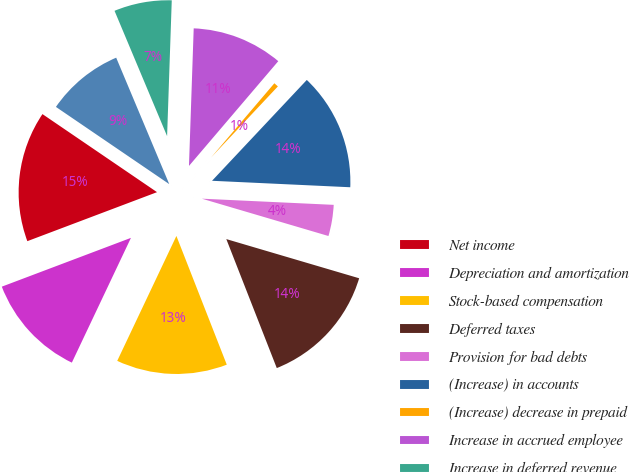<chart> <loc_0><loc_0><loc_500><loc_500><pie_chart><fcel>Net income<fcel>Depreciation and amortization<fcel>Stock-based compensation<fcel>Deferred taxes<fcel>Provision for bad debts<fcel>(Increase) in accounts<fcel>(Increase) decrease in prepaid<fcel>Increase in accrued employee<fcel>Increase in deferred revenue<fcel>Increase in accounts payable<nl><fcel>15.27%<fcel>12.21%<fcel>12.98%<fcel>14.5%<fcel>3.82%<fcel>13.74%<fcel>0.77%<fcel>10.69%<fcel>6.87%<fcel>9.16%<nl></chart> 